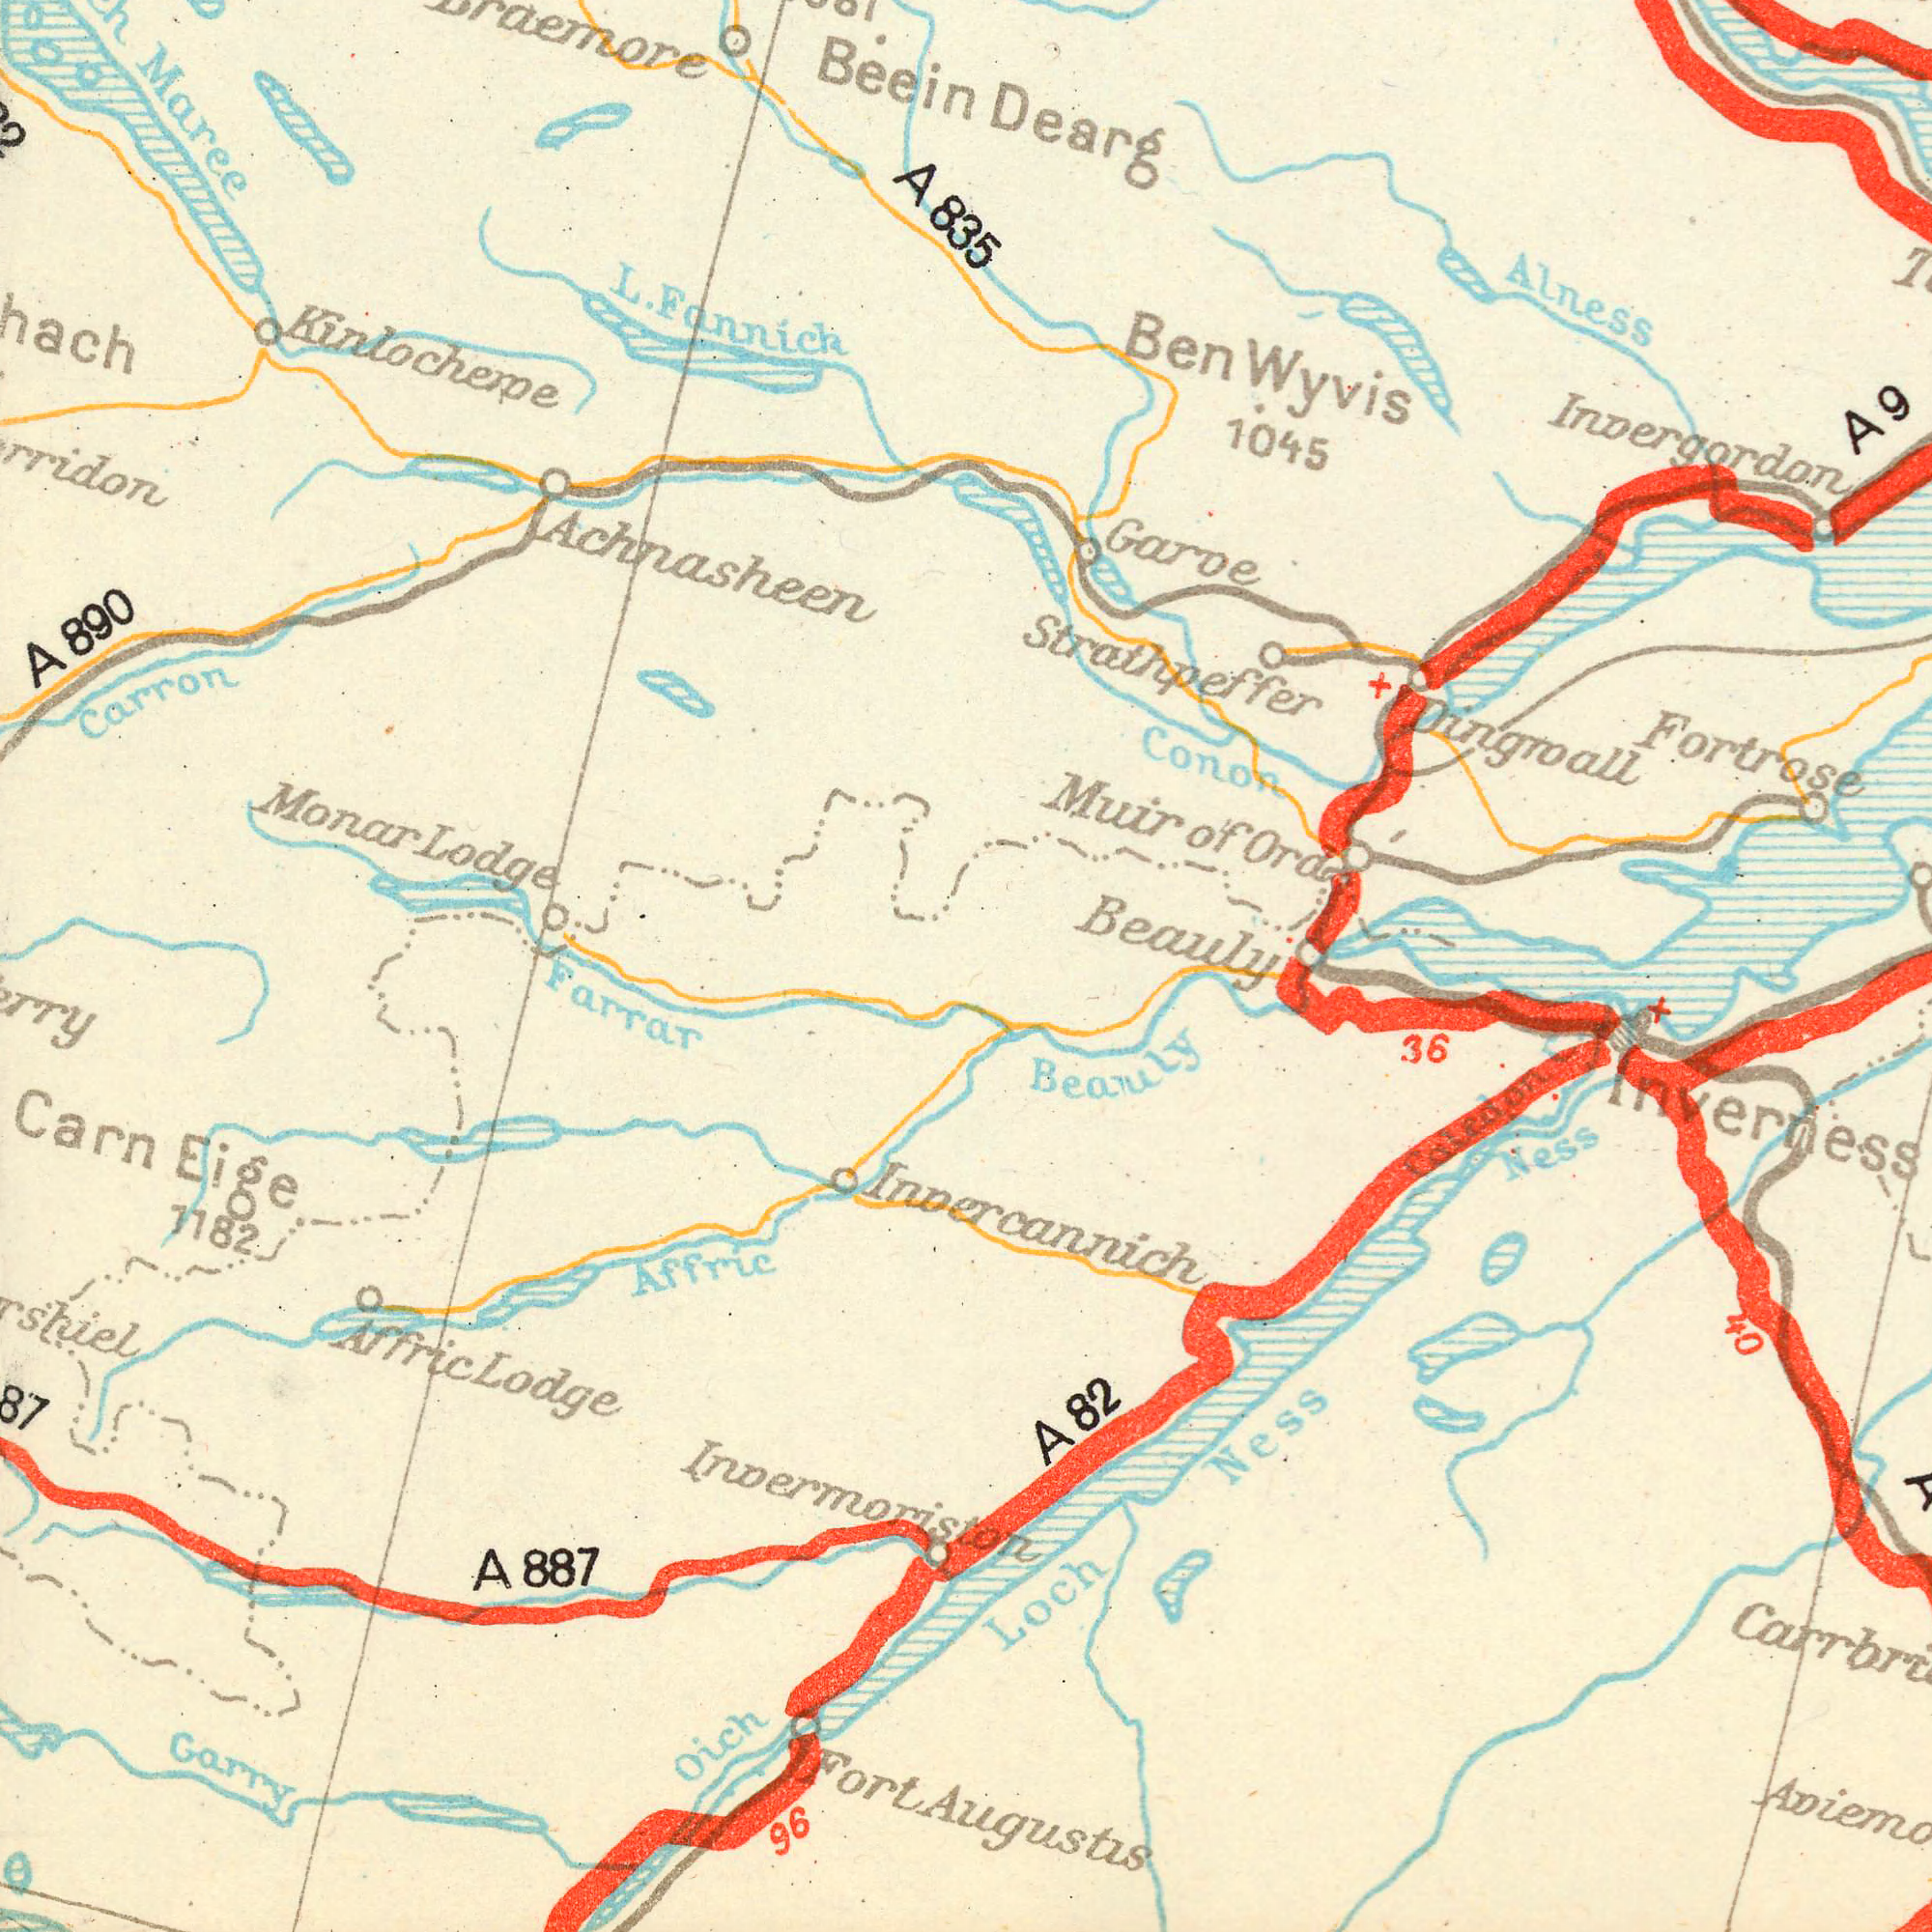What text is visible in the lower-left corner? Farrar 1182 Invermoristor 96 A 887 Oich Affrie Garry Carn Eige Afric Lodge Fort What text can you see in the bottom-right section? Loch Ness 36 Ness Inverness Calidon Beauly A 82 Augustis Invercannich 40 What text appears in the top-right area of the image? Dearg Dingroall 1045 Fortrose Alness Garve Invergordon Beauly Muir of Ora Strathpeffer Conon Ben Wyvis A 9 What text can you see in the top-left section? Monar Lodge L. Fannich Carron Maree A 890 Beein Achnasheen Kinlocheme A 835 